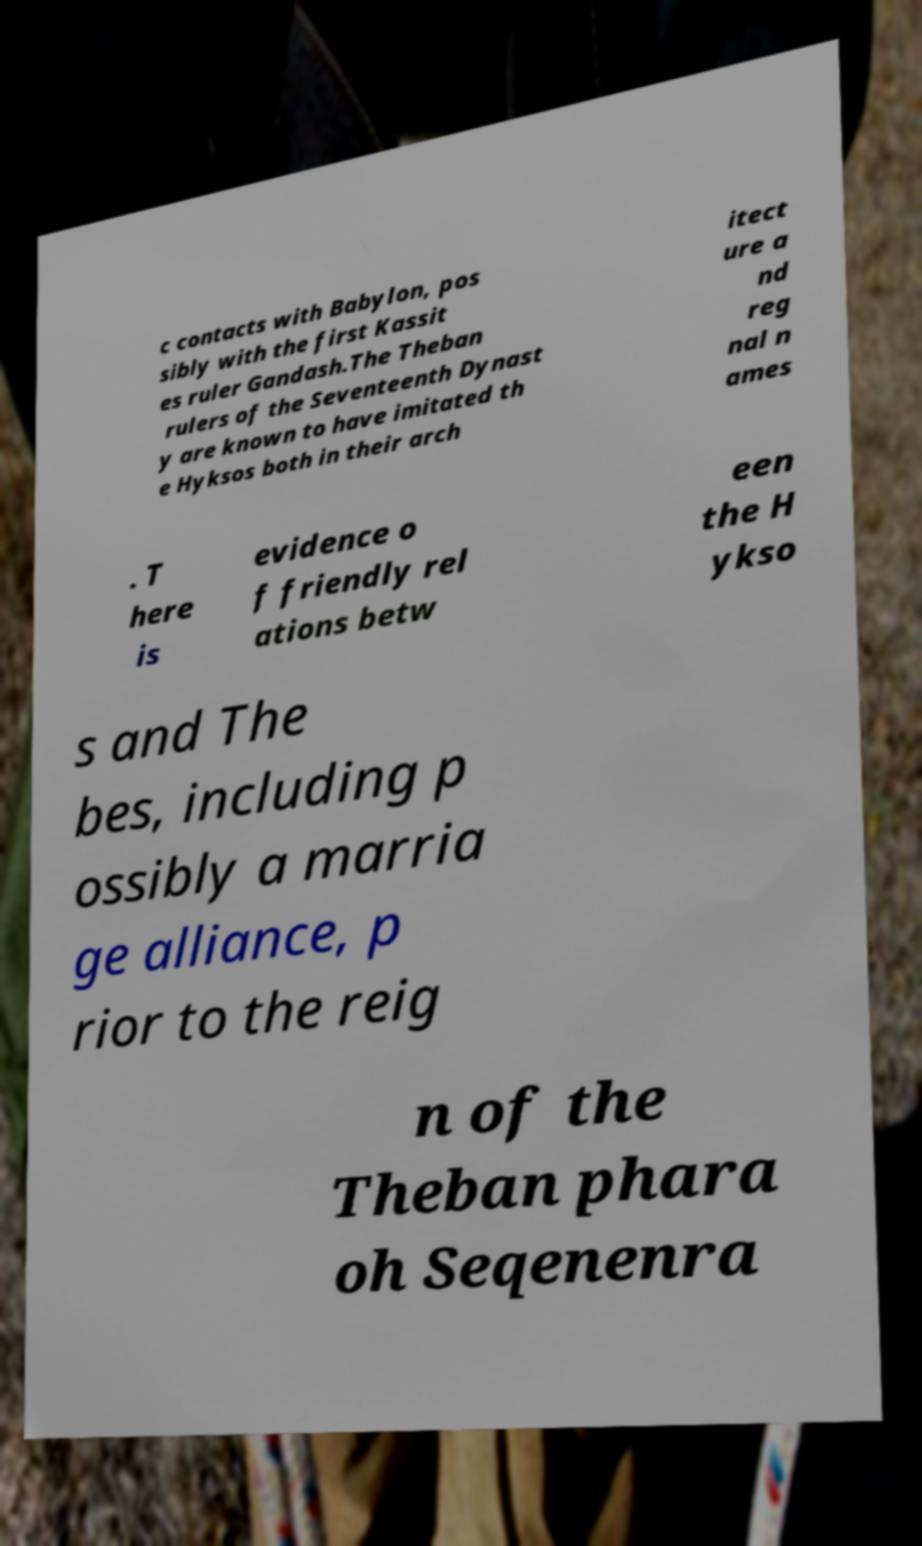Could you extract and type out the text from this image? c contacts with Babylon, pos sibly with the first Kassit es ruler Gandash.The Theban rulers of the Seventeenth Dynast y are known to have imitated th e Hyksos both in their arch itect ure a nd reg nal n ames . T here is evidence o f friendly rel ations betw een the H ykso s and The bes, including p ossibly a marria ge alliance, p rior to the reig n of the Theban phara oh Seqenenra 